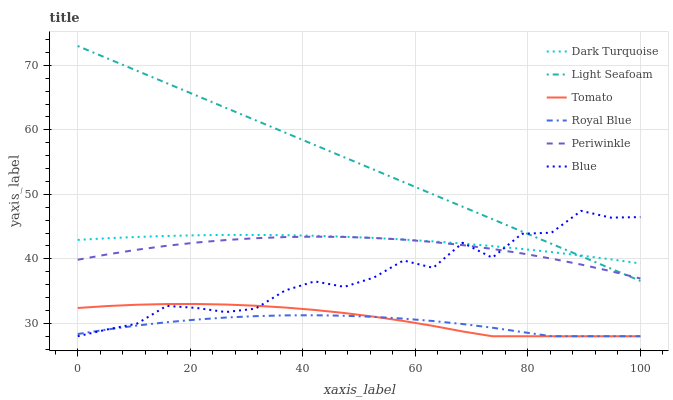Does Blue have the minimum area under the curve?
Answer yes or no. No. Does Blue have the maximum area under the curve?
Answer yes or no. No. Is Dark Turquoise the smoothest?
Answer yes or no. No. Is Dark Turquoise the roughest?
Answer yes or no. No. Does Dark Turquoise have the lowest value?
Answer yes or no. No. Does Blue have the highest value?
Answer yes or no. No. Is Royal Blue less than Light Seafoam?
Answer yes or no. Yes. Is Periwinkle greater than Tomato?
Answer yes or no. Yes. Does Royal Blue intersect Light Seafoam?
Answer yes or no. No. 